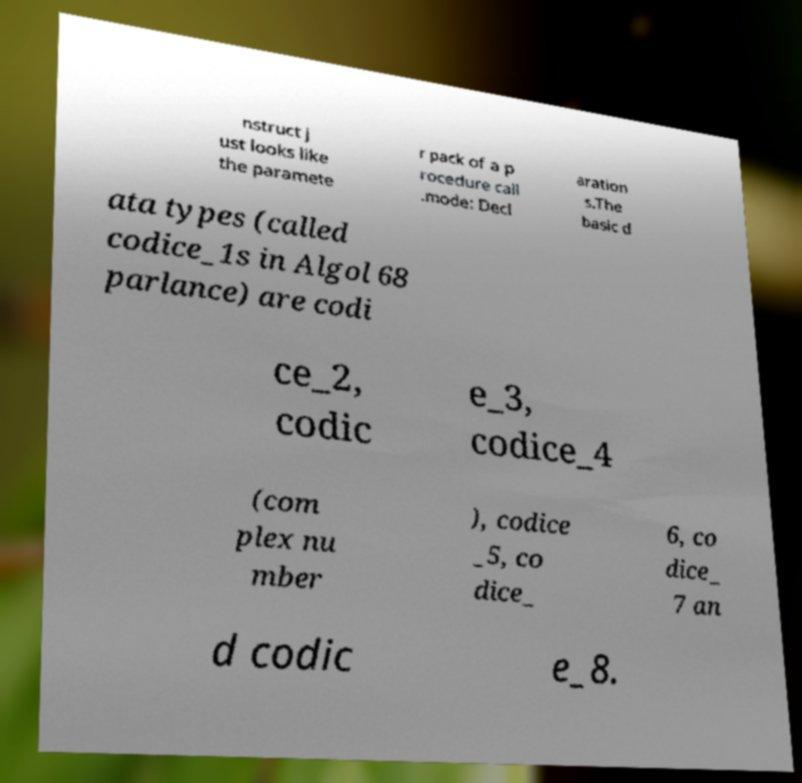Please identify and transcribe the text found in this image. nstruct j ust looks like the paramete r pack of a p rocedure call .mode: Decl aration s.The basic d ata types (called codice_1s in Algol 68 parlance) are codi ce_2, codic e_3, codice_4 (com plex nu mber ), codice _5, co dice_ 6, co dice_ 7 an d codic e_8. 